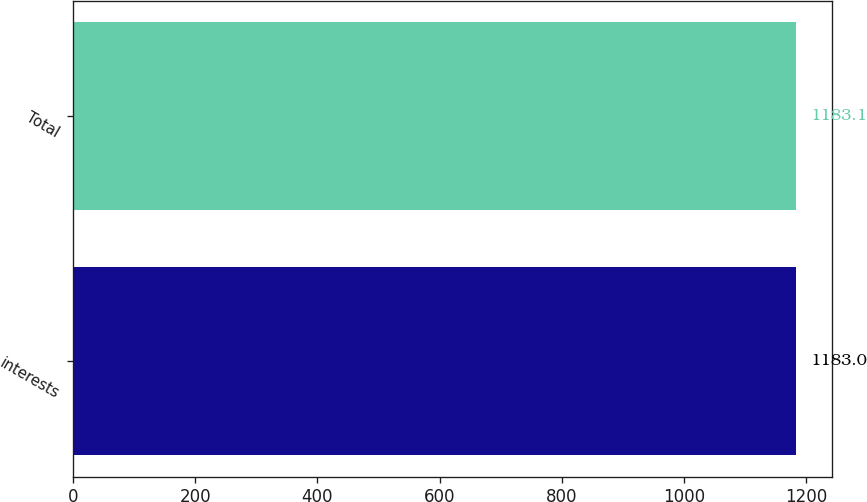Convert chart to OTSL. <chart><loc_0><loc_0><loc_500><loc_500><bar_chart><fcel>interests<fcel>Total<nl><fcel>1183<fcel>1183.1<nl></chart> 